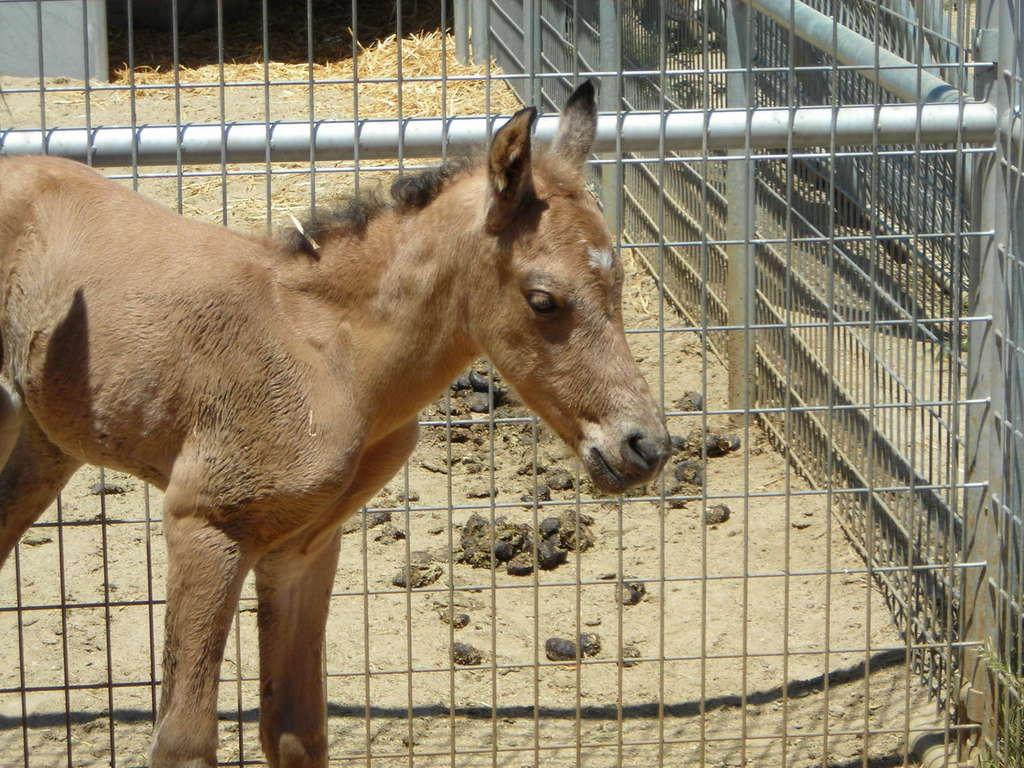What animal is present in the image? There is a donkey in the image. Where is the donkey located in the image? The donkey is at the bottom of the image. What can be seen in the background of the image? There is a mesh and grass in the background of the image. What type of plants are on the list in the image? There is no list present in the image, so it is not possible to determine what type of plants might be on it. 